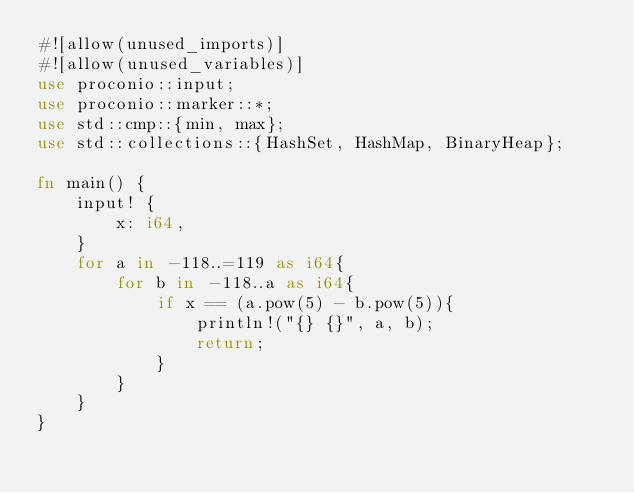<code> <loc_0><loc_0><loc_500><loc_500><_Rust_>#![allow(unused_imports)]
#![allow(unused_variables)]
use proconio::input;
use proconio::marker::*;
use std::cmp::{min, max};
use std::collections::{HashSet, HashMap, BinaryHeap};

fn main() {
    input! {
        x: i64,
    }
    for a in -118..=119 as i64{
        for b in -118..a as i64{
            if x == (a.pow(5) - b.pow(5)){
                println!("{} {}", a, b);
                return;
            }
        }
    }
}
</code> 